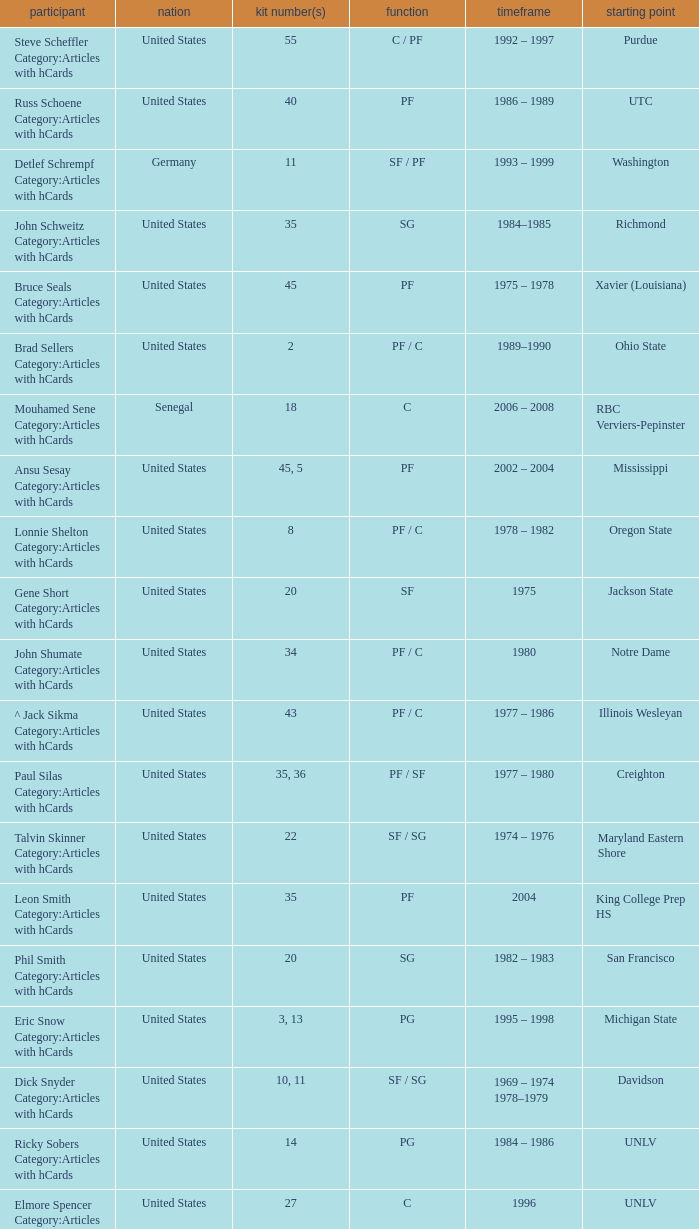Who wears the jersey number 20 and has the position of SG? Phil Smith Category:Articles with hCards, Jon Sundvold Category:Articles with hCards. 